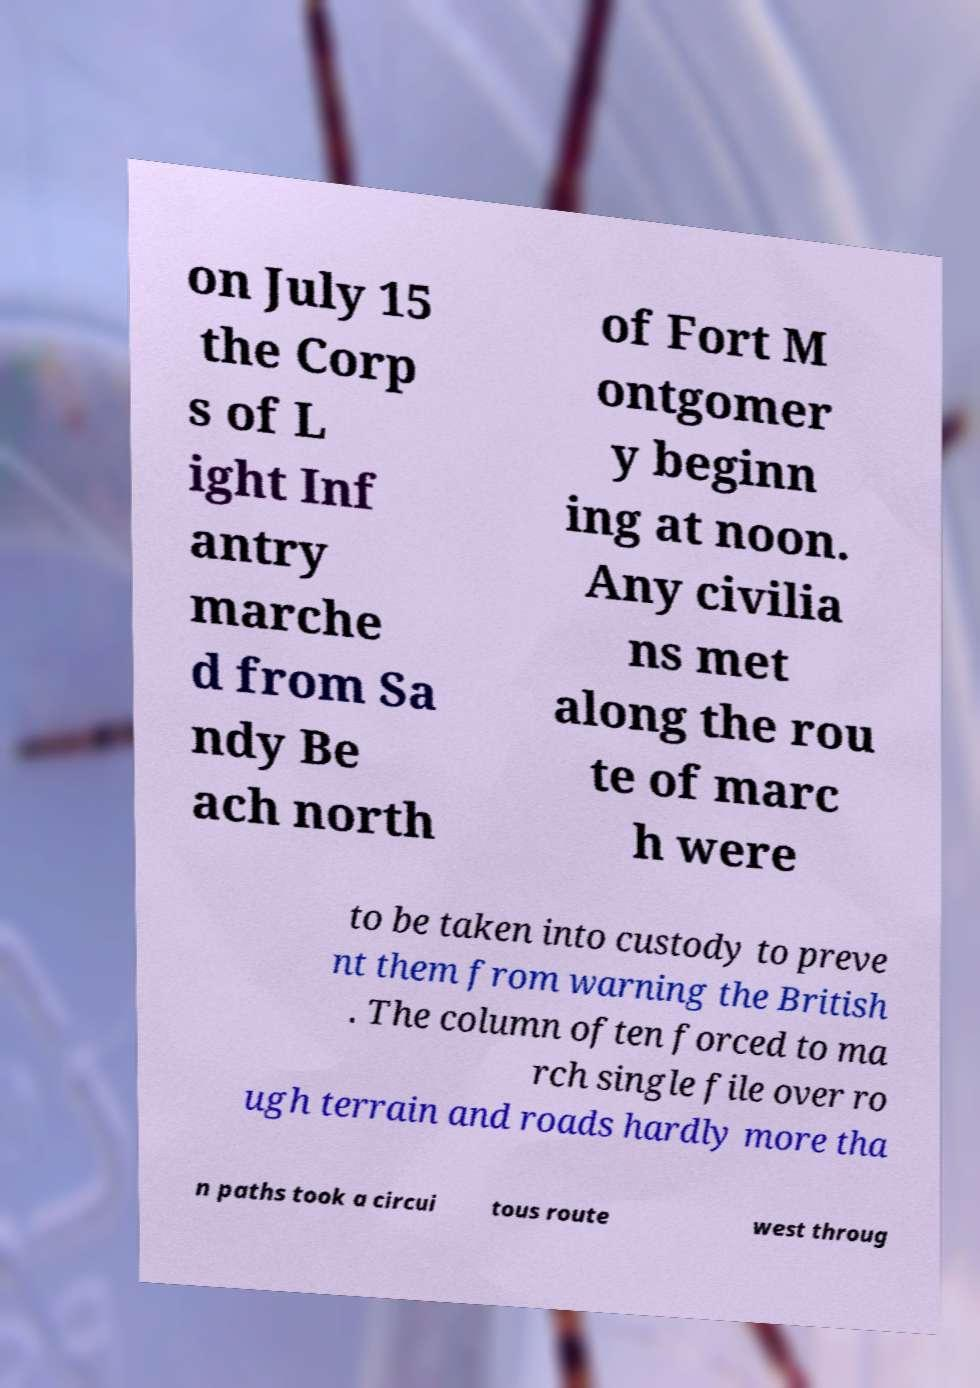Please read and relay the text visible in this image. What does it say? on July 15 the Corp s of L ight Inf antry marche d from Sa ndy Be ach north of Fort M ontgomer y beginn ing at noon. Any civilia ns met along the rou te of marc h were to be taken into custody to preve nt them from warning the British . The column often forced to ma rch single file over ro ugh terrain and roads hardly more tha n paths took a circui tous route west throug 